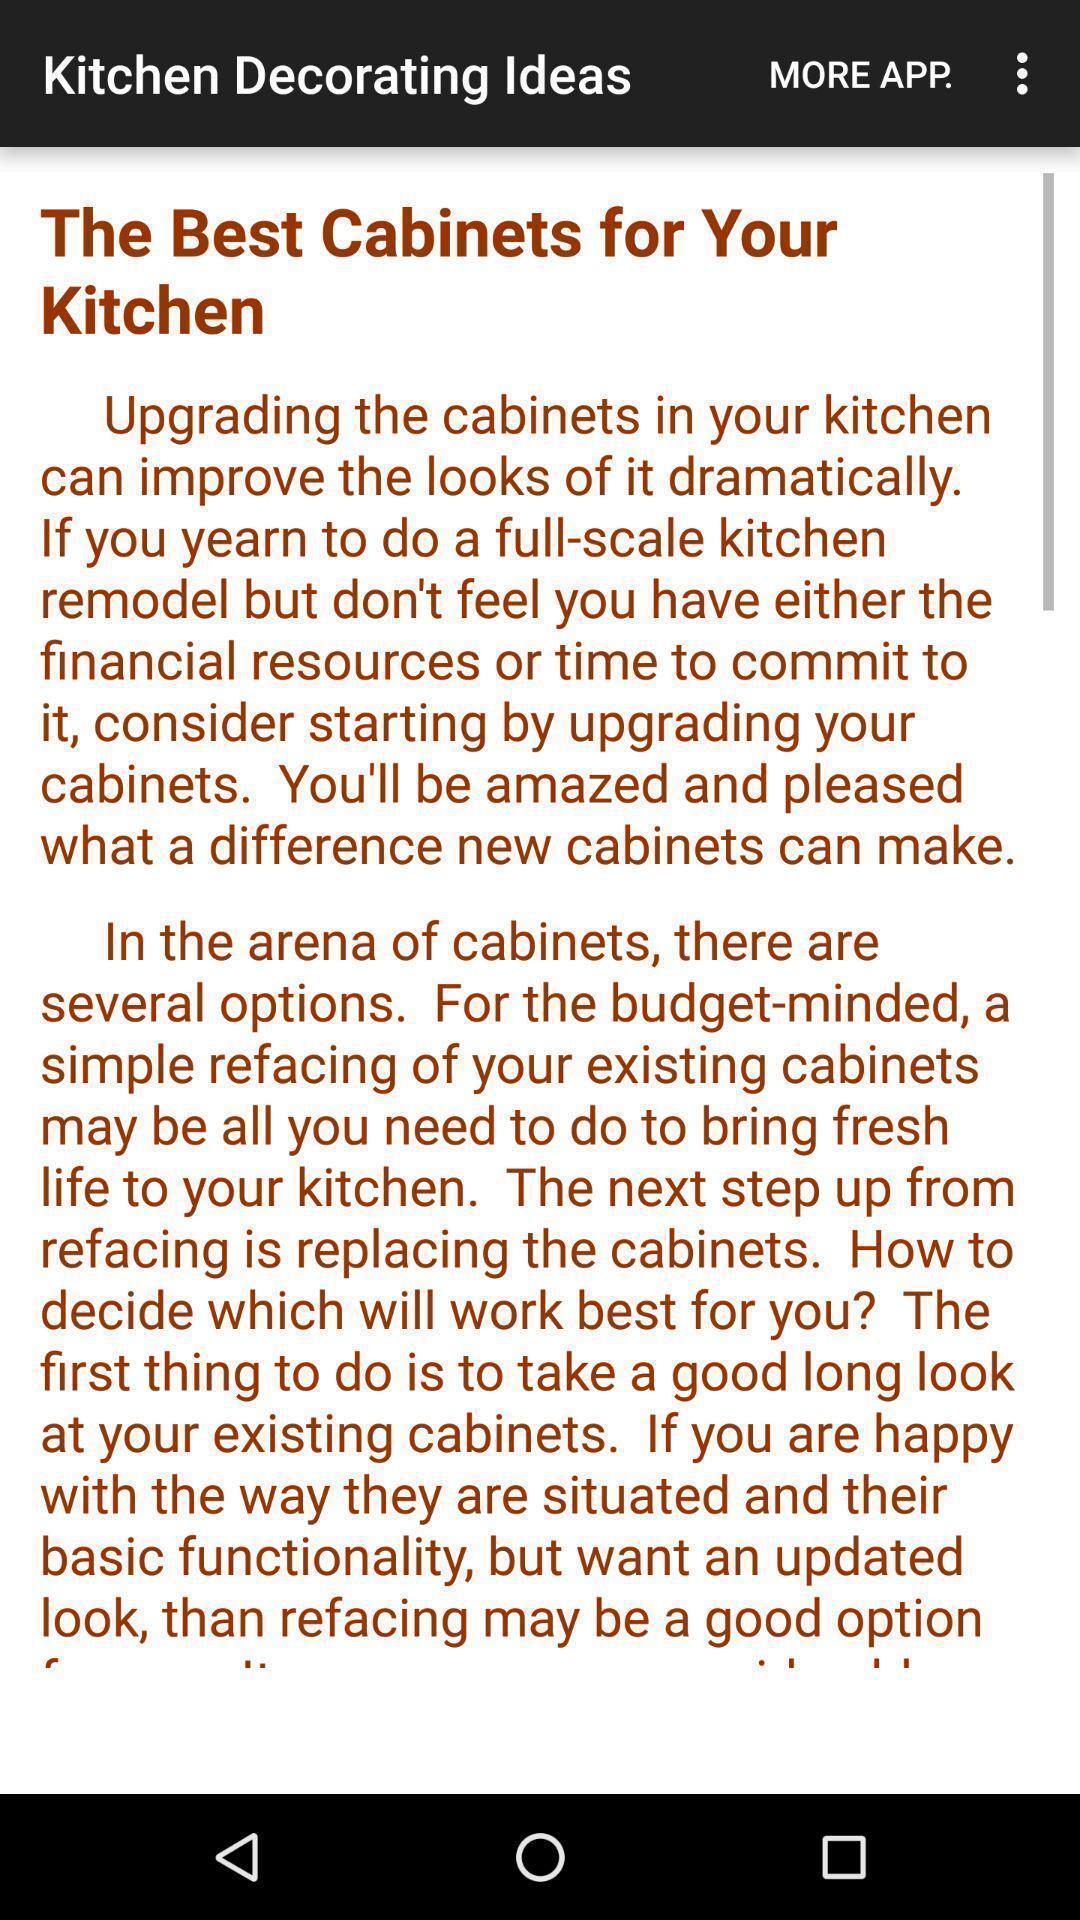What can you discern from this picture? Page displaying with information about decorating ideas for kitchen. 